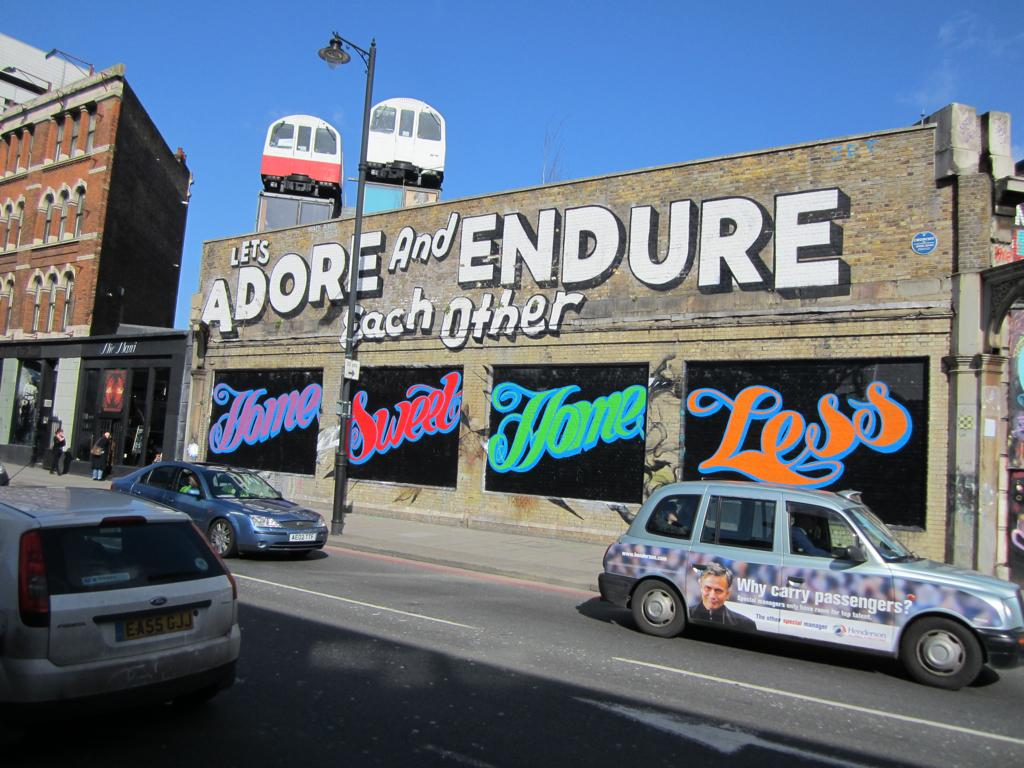Provide a one-sentence caption for the provided image. An artistic sign painted on the side of a building encouraging people to "Adore and Endure Each Other". 